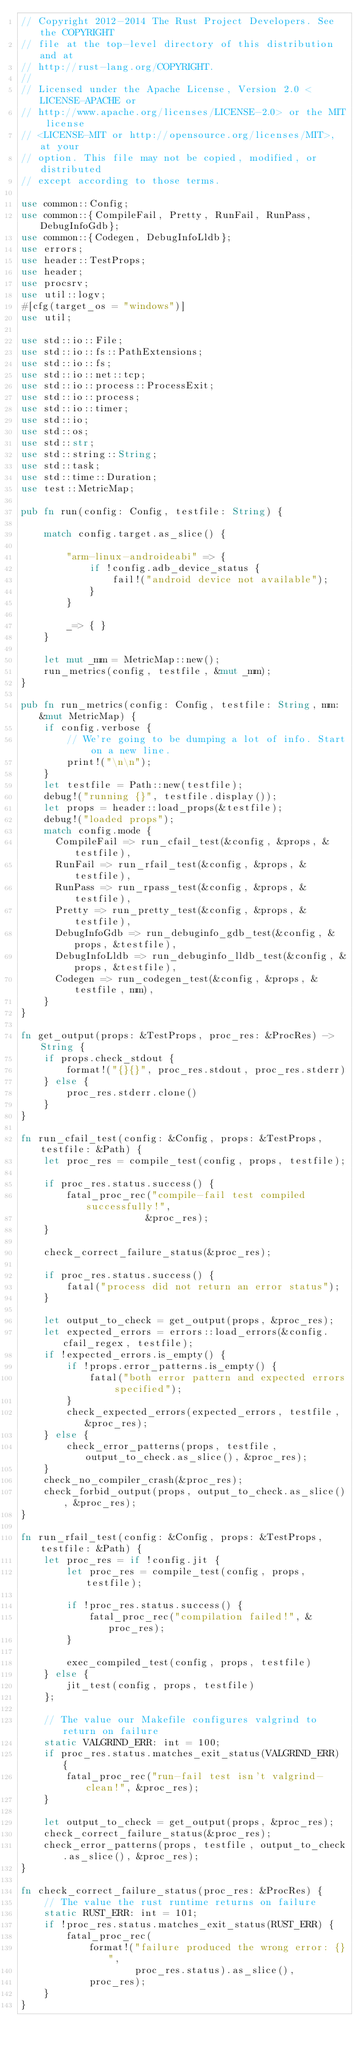<code> <loc_0><loc_0><loc_500><loc_500><_Rust_>// Copyright 2012-2014 The Rust Project Developers. See the COPYRIGHT
// file at the top-level directory of this distribution and at
// http://rust-lang.org/COPYRIGHT.
//
// Licensed under the Apache License, Version 2.0 <LICENSE-APACHE or
// http://www.apache.org/licenses/LICENSE-2.0> or the MIT license
// <LICENSE-MIT or http://opensource.org/licenses/MIT>, at your
// option. This file may not be copied, modified, or distributed
// except according to those terms.

use common::Config;
use common::{CompileFail, Pretty, RunFail, RunPass, DebugInfoGdb};
use common::{Codegen, DebugInfoLldb};
use errors;
use header::TestProps;
use header;
use procsrv;
use util::logv;
#[cfg(target_os = "windows")]
use util;

use std::io::File;
use std::io::fs::PathExtensions;
use std::io::fs;
use std::io::net::tcp;
use std::io::process::ProcessExit;
use std::io::process;
use std::io::timer;
use std::io;
use std::os;
use std::str;
use std::string::String;
use std::task;
use std::time::Duration;
use test::MetricMap;

pub fn run(config: Config, testfile: String) {

    match config.target.as_slice() {

        "arm-linux-androideabi" => {
            if !config.adb_device_status {
                fail!("android device not available");
            }
        }

        _=> { }
    }

    let mut _mm = MetricMap::new();
    run_metrics(config, testfile, &mut _mm);
}

pub fn run_metrics(config: Config, testfile: String, mm: &mut MetricMap) {
    if config.verbose {
        // We're going to be dumping a lot of info. Start on a new line.
        print!("\n\n");
    }
    let testfile = Path::new(testfile);
    debug!("running {}", testfile.display());
    let props = header::load_props(&testfile);
    debug!("loaded props");
    match config.mode {
      CompileFail => run_cfail_test(&config, &props, &testfile),
      RunFail => run_rfail_test(&config, &props, &testfile),
      RunPass => run_rpass_test(&config, &props, &testfile),
      Pretty => run_pretty_test(&config, &props, &testfile),
      DebugInfoGdb => run_debuginfo_gdb_test(&config, &props, &testfile),
      DebugInfoLldb => run_debuginfo_lldb_test(&config, &props, &testfile),
      Codegen => run_codegen_test(&config, &props, &testfile, mm),
    }
}

fn get_output(props: &TestProps, proc_res: &ProcRes) -> String {
    if props.check_stdout {
        format!("{}{}", proc_res.stdout, proc_res.stderr)
    } else {
        proc_res.stderr.clone()
    }
}

fn run_cfail_test(config: &Config, props: &TestProps, testfile: &Path) {
    let proc_res = compile_test(config, props, testfile);

    if proc_res.status.success() {
        fatal_proc_rec("compile-fail test compiled successfully!",
                      &proc_res);
    }

    check_correct_failure_status(&proc_res);

    if proc_res.status.success() {
        fatal("process did not return an error status");
    }

    let output_to_check = get_output(props, &proc_res);
    let expected_errors = errors::load_errors(&config.cfail_regex, testfile);
    if !expected_errors.is_empty() {
        if !props.error_patterns.is_empty() {
            fatal("both error pattern and expected errors specified");
        }
        check_expected_errors(expected_errors, testfile, &proc_res);
    } else {
        check_error_patterns(props, testfile, output_to_check.as_slice(), &proc_res);
    }
    check_no_compiler_crash(&proc_res);
    check_forbid_output(props, output_to_check.as_slice(), &proc_res);
}

fn run_rfail_test(config: &Config, props: &TestProps, testfile: &Path) {
    let proc_res = if !config.jit {
        let proc_res = compile_test(config, props, testfile);

        if !proc_res.status.success() {
            fatal_proc_rec("compilation failed!", &proc_res);
        }

        exec_compiled_test(config, props, testfile)
    } else {
        jit_test(config, props, testfile)
    };

    // The value our Makefile configures valgrind to return on failure
    static VALGRIND_ERR: int = 100;
    if proc_res.status.matches_exit_status(VALGRIND_ERR) {
        fatal_proc_rec("run-fail test isn't valgrind-clean!", &proc_res);
    }

    let output_to_check = get_output(props, &proc_res);
    check_correct_failure_status(&proc_res);
    check_error_patterns(props, testfile, output_to_check.as_slice(), &proc_res);
}

fn check_correct_failure_status(proc_res: &ProcRes) {
    // The value the rust runtime returns on failure
    static RUST_ERR: int = 101;
    if !proc_res.status.matches_exit_status(RUST_ERR) {
        fatal_proc_rec(
            format!("failure produced the wrong error: {}",
                    proc_res.status).as_slice(),
            proc_res);
    }
}
</code> 